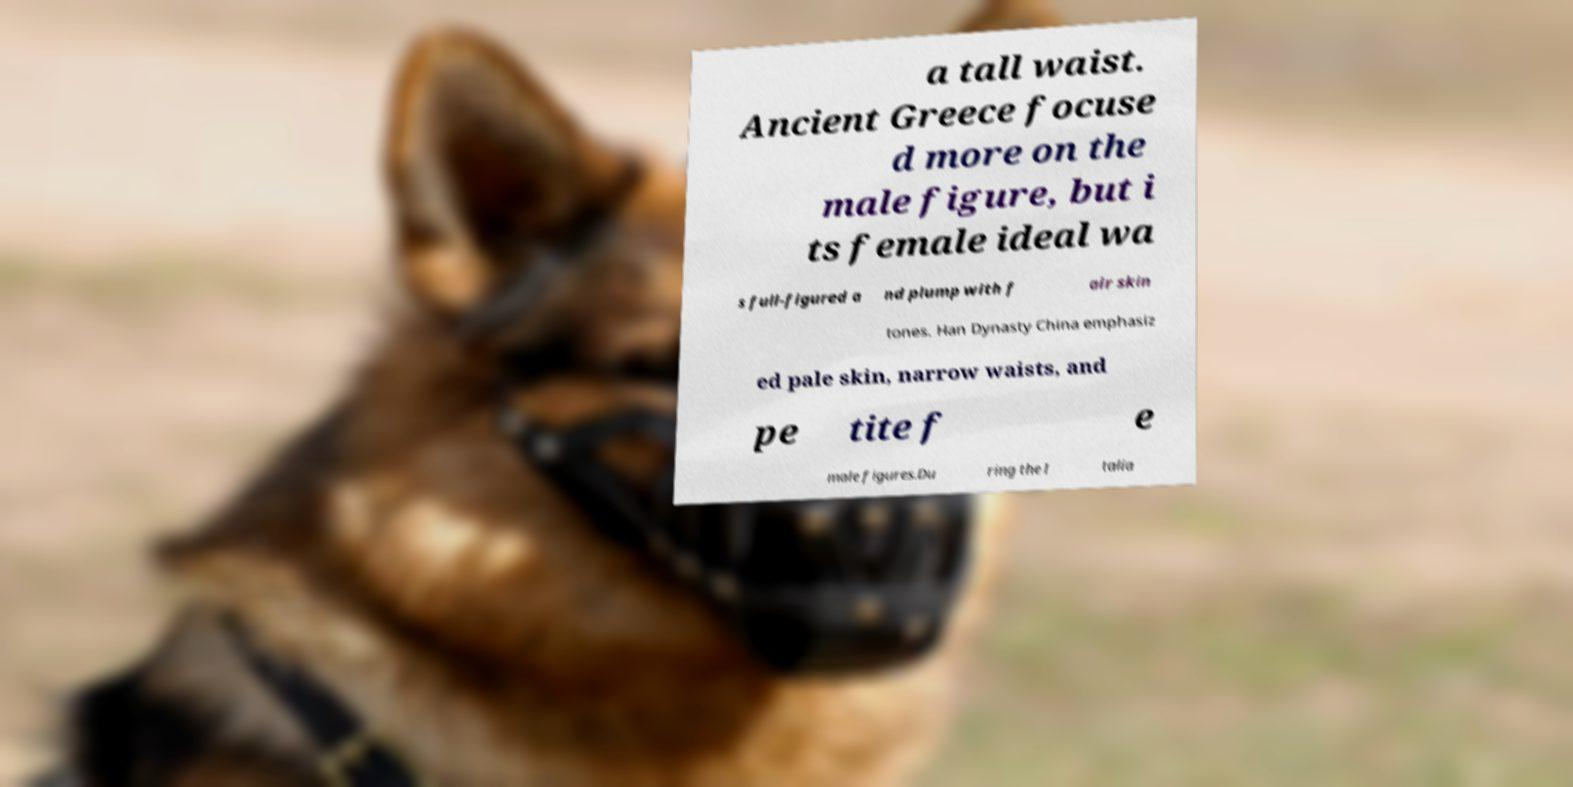For documentation purposes, I need the text within this image transcribed. Could you provide that? a tall waist. Ancient Greece focuse d more on the male figure, but i ts female ideal wa s full-figured a nd plump with f air skin tones. Han Dynasty China emphasiz ed pale skin, narrow waists, and pe tite f e male figures.Du ring the I talia 